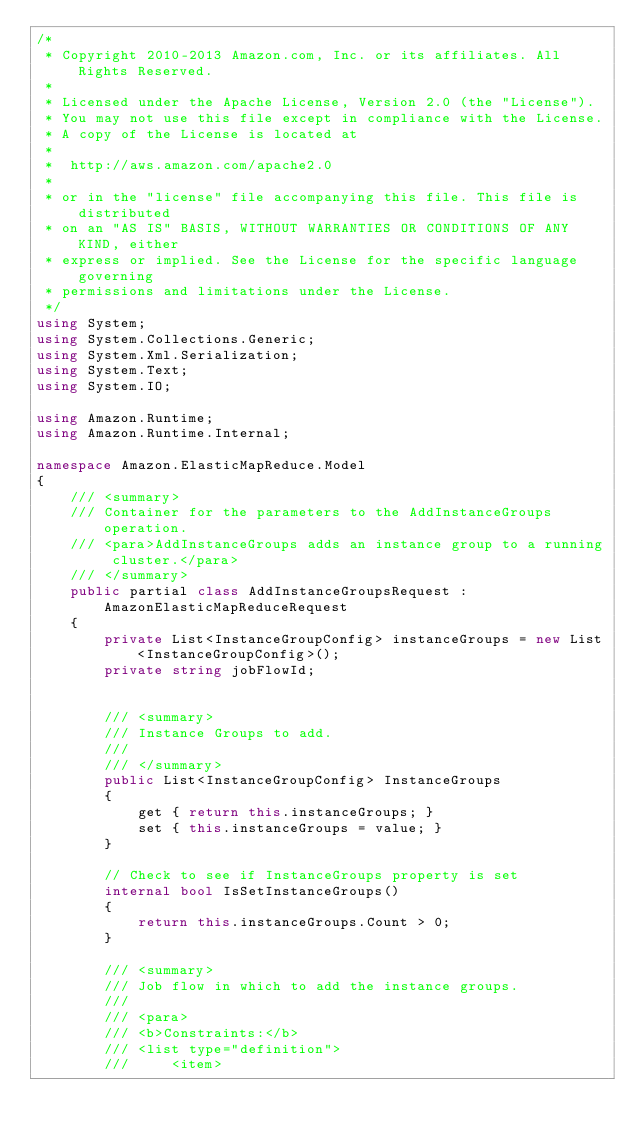Convert code to text. <code><loc_0><loc_0><loc_500><loc_500><_C#_>/*
 * Copyright 2010-2013 Amazon.com, Inc. or its affiliates. All Rights Reserved.
 * 
 * Licensed under the Apache License, Version 2.0 (the "License").
 * You may not use this file except in compliance with the License.
 * A copy of the License is located at
 * 
 *  http://aws.amazon.com/apache2.0
 * 
 * or in the "license" file accompanying this file. This file is distributed
 * on an "AS IS" BASIS, WITHOUT WARRANTIES OR CONDITIONS OF ANY KIND, either
 * express or implied. See the License for the specific language governing
 * permissions and limitations under the License.
 */
using System;
using System.Collections.Generic;
using System.Xml.Serialization;
using System.Text;
using System.IO;

using Amazon.Runtime;
using Amazon.Runtime.Internal;

namespace Amazon.ElasticMapReduce.Model
{
    /// <summary>
    /// Container for the parameters to the AddInstanceGroups operation.
    /// <para>AddInstanceGroups adds an instance group to a running cluster.</para>
    /// </summary>
    public partial class AddInstanceGroupsRequest : AmazonElasticMapReduceRequest
    {
        private List<InstanceGroupConfig> instanceGroups = new List<InstanceGroupConfig>();
        private string jobFlowId;


        /// <summary>
        /// Instance Groups to add.
        ///  
        /// </summary>
        public List<InstanceGroupConfig> InstanceGroups
        {
            get { return this.instanceGroups; }
            set { this.instanceGroups = value; }
        }

        // Check to see if InstanceGroups property is set
        internal bool IsSetInstanceGroups()
        {
            return this.instanceGroups.Count > 0;
        }

        /// <summary>
        /// Job flow in which to add the instance groups.
        ///  
        /// <para>
        /// <b>Constraints:</b>
        /// <list type="definition">
        ///     <item></code> 